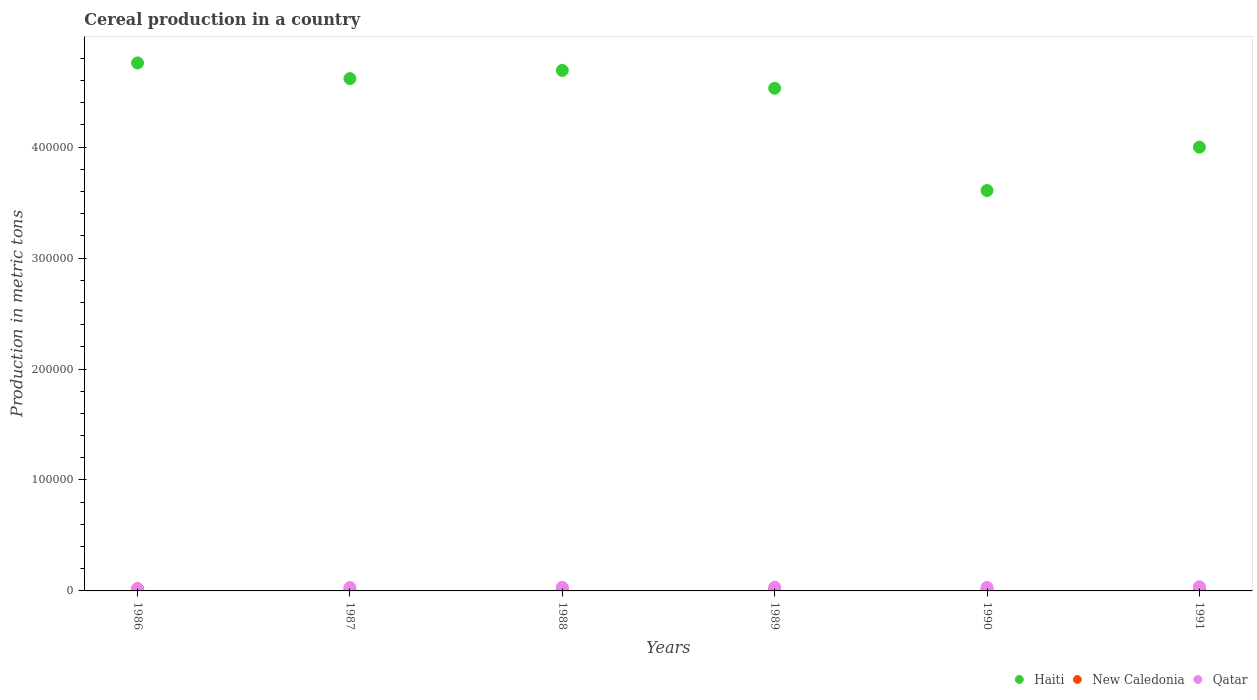Is the number of dotlines equal to the number of legend labels?
Keep it short and to the point. Yes. What is the total cereal production in Qatar in 1990?
Your answer should be very brief. 3135. Across all years, what is the maximum total cereal production in Haiti?
Offer a very short reply. 4.76e+05. Across all years, what is the minimum total cereal production in New Caledonia?
Your answer should be compact. 692. In which year was the total cereal production in Qatar minimum?
Provide a succinct answer. 1986. What is the total total cereal production in New Caledonia in the graph?
Provide a short and direct response. 6410. What is the difference between the total cereal production in New Caledonia in 1988 and that in 1991?
Provide a short and direct response. 263. What is the difference between the total cereal production in New Caledonia in 1991 and the total cereal production in Qatar in 1988?
Keep it short and to the point. -2488. What is the average total cereal production in Qatar per year?
Ensure brevity in your answer.  3067. In the year 1988, what is the difference between the total cereal production in New Caledonia and total cereal production in Qatar?
Provide a succinct answer. -2225. What is the ratio of the total cereal production in New Caledonia in 1989 to that in 1991?
Provide a succinct answer. 1.08. Is the difference between the total cereal production in New Caledonia in 1987 and 1991 greater than the difference between the total cereal production in Qatar in 1987 and 1991?
Make the answer very short. Yes. What is the difference between the highest and the second highest total cereal production in Haiti?
Make the answer very short. 6732. What is the difference between the highest and the lowest total cereal production in Haiti?
Your answer should be compact. 1.15e+05. In how many years, is the total cereal production in Haiti greater than the average total cereal production in Haiti taken over all years?
Offer a very short reply. 4. Is the sum of the total cereal production in Haiti in 1986 and 1991 greater than the maximum total cereal production in Qatar across all years?
Offer a terse response. Yes. Does the total cereal production in New Caledonia monotonically increase over the years?
Provide a short and direct response. No. Is the total cereal production in New Caledonia strictly greater than the total cereal production in Qatar over the years?
Your answer should be very brief. No. Is the total cereal production in Haiti strictly less than the total cereal production in New Caledonia over the years?
Give a very brief answer. No. How many dotlines are there?
Provide a short and direct response. 3. How many years are there in the graph?
Provide a succinct answer. 6. What is the difference between two consecutive major ticks on the Y-axis?
Provide a short and direct response. 1.00e+05. Does the graph contain grids?
Your answer should be very brief. No. What is the title of the graph?
Your answer should be very brief. Cereal production in a country. Does "Barbados" appear as one of the legend labels in the graph?
Your response must be concise. No. What is the label or title of the Y-axis?
Give a very brief answer. Production in metric tons. What is the Production in metric tons of Haiti in 1986?
Give a very brief answer. 4.76e+05. What is the Production in metric tons in New Caledonia in 1986?
Offer a very short reply. 1947. What is the Production in metric tons in Qatar in 1986?
Ensure brevity in your answer.  1977. What is the Production in metric tons in Haiti in 1987?
Give a very brief answer. 4.62e+05. What is the Production in metric tons of New Caledonia in 1987?
Ensure brevity in your answer.  692. What is the Production in metric tons in Qatar in 1987?
Give a very brief answer. 3020. What is the Production in metric tons in Haiti in 1988?
Your answer should be compact. 4.69e+05. What is the Production in metric tons in New Caledonia in 1988?
Keep it short and to the point. 999. What is the Production in metric tons in Qatar in 1988?
Offer a very short reply. 3224. What is the Production in metric tons in Haiti in 1989?
Your answer should be compact. 4.53e+05. What is the Production in metric tons in New Caledonia in 1989?
Ensure brevity in your answer.  792. What is the Production in metric tons of Qatar in 1989?
Offer a very short reply. 3297. What is the Production in metric tons in Haiti in 1990?
Provide a short and direct response. 3.61e+05. What is the Production in metric tons of New Caledonia in 1990?
Provide a short and direct response. 1244. What is the Production in metric tons of Qatar in 1990?
Keep it short and to the point. 3135. What is the Production in metric tons in Haiti in 1991?
Provide a succinct answer. 4.00e+05. What is the Production in metric tons in New Caledonia in 1991?
Offer a terse response. 736. What is the Production in metric tons of Qatar in 1991?
Offer a terse response. 3749. Across all years, what is the maximum Production in metric tons of Haiti?
Make the answer very short. 4.76e+05. Across all years, what is the maximum Production in metric tons in New Caledonia?
Make the answer very short. 1947. Across all years, what is the maximum Production in metric tons of Qatar?
Give a very brief answer. 3749. Across all years, what is the minimum Production in metric tons of Haiti?
Keep it short and to the point. 3.61e+05. Across all years, what is the minimum Production in metric tons in New Caledonia?
Your response must be concise. 692. Across all years, what is the minimum Production in metric tons of Qatar?
Provide a short and direct response. 1977. What is the total Production in metric tons of Haiti in the graph?
Make the answer very short. 2.62e+06. What is the total Production in metric tons in New Caledonia in the graph?
Provide a short and direct response. 6410. What is the total Production in metric tons of Qatar in the graph?
Keep it short and to the point. 1.84e+04. What is the difference between the Production in metric tons of Haiti in 1986 and that in 1987?
Provide a succinct answer. 1.41e+04. What is the difference between the Production in metric tons in New Caledonia in 1986 and that in 1987?
Offer a very short reply. 1255. What is the difference between the Production in metric tons in Qatar in 1986 and that in 1987?
Keep it short and to the point. -1043. What is the difference between the Production in metric tons of Haiti in 1986 and that in 1988?
Give a very brief answer. 6732. What is the difference between the Production in metric tons of New Caledonia in 1986 and that in 1988?
Your answer should be compact. 948. What is the difference between the Production in metric tons in Qatar in 1986 and that in 1988?
Your answer should be compact. -1247. What is the difference between the Production in metric tons of Haiti in 1986 and that in 1989?
Offer a terse response. 2.28e+04. What is the difference between the Production in metric tons of New Caledonia in 1986 and that in 1989?
Make the answer very short. 1155. What is the difference between the Production in metric tons of Qatar in 1986 and that in 1989?
Offer a very short reply. -1320. What is the difference between the Production in metric tons in Haiti in 1986 and that in 1990?
Provide a short and direct response. 1.15e+05. What is the difference between the Production in metric tons in New Caledonia in 1986 and that in 1990?
Provide a succinct answer. 703. What is the difference between the Production in metric tons in Qatar in 1986 and that in 1990?
Provide a short and direct response. -1158. What is the difference between the Production in metric tons in Haiti in 1986 and that in 1991?
Keep it short and to the point. 7.59e+04. What is the difference between the Production in metric tons in New Caledonia in 1986 and that in 1991?
Your answer should be very brief. 1211. What is the difference between the Production in metric tons of Qatar in 1986 and that in 1991?
Provide a succinct answer. -1772. What is the difference between the Production in metric tons of Haiti in 1987 and that in 1988?
Your answer should be very brief. -7377. What is the difference between the Production in metric tons in New Caledonia in 1987 and that in 1988?
Offer a terse response. -307. What is the difference between the Production in metric tons in Qatar in 1987 and that in 1988?
Offer a very short reply. -204. What is the difference between the Production in metric tons of Haiti in 1987 and that in 1989?
Keep it short and to the point. 8706. What is the difference between the Production in metric tons in New Caledonia in 1987 and that in 1989?
Make the answer very short. -100. What is the difference between the Production in metric tons of Qatar in 1987 and that in 1989?
Provide a short and direct response. -277. What is the difference between the Production in metric tons in Haiti in 1987 and that in 1990?
Provide a short and direct response. 1.01e+05. What is the difference between the Production in metric tons in New Caledonia in 1987 and that in 1990?
Give a very brief answer. -552. What is the difference between the Production in metric tons of Qatar in 1987 and that in 1990?
Ensure brevity in your answer.  -115. What is the difference between the Production in metric tons of Haiti in 1987 and that in 1991?
Make the answer very short. 6.18e+04. What is the difference between the Production in metric tons in New Caledonia in 1987 and that in 1991?
Offer a terse response. -44. What is the difference between the Production in metric tons of Qatar in 1987 and that in 1991?
Give a very brief answer. -729. What is the difference between the Production in metric tons in Haiti in 1988 and that in 1989?
Your answer should be compact. 1.61e+04. What is the difference between the Production in metric tons in New Caledonia in 1988 and that in 1989?
Your answer should be very brief. 207. What is the difference between the Production in metric tons of Qatar in 1988 and that in 1989?
Make the answer very short. -73. What is the difference between the Production in metric tons of Haiti in 1988 and that in 1990?
Offer a very short reply. 1.08e+05. What is the difference between the Production in metric tons in New Caledonia in 1988 and that in 1990?
Make the answer very short. -245. What is the difference between the Production in metric tons in Qatar in 1988 and that in 1990?
Ensure brevity in your answer.  89. What is the difference between the Production in metric tons of Haiti in 1988 and that in 1991?
Ensure brevity in your answer.  6.92e+04. What is the difference between the Production in metric tons in New Caledonia in 1988 and that in 1991?
Provide a succinct answer. 263. What is the difference between the Production in metric tons of Qatar in 1988 and that in 1991?
Make the answer very short. -525. What is the difference between the Production in metric tons in Haiti in 1989 and that in 1990?
Offer a very short reply. 9.22e+04. What is the difference between the Production in metric tons in New Caledonia in 1989 and that in 1990?
Give a very brief answer. -452. What is the difference between the Production in metric tons in Qatar in 1989 and that in 1990?
Keep it short and to the point. 162. What is the difference between the Production in metric tons in Haiti in 1989 and that in 1991?
Provide a short and direct response. 5.31e+04. What is the difference between the Production in metric tons of Qatar in 1989 and that in 1991?
Provide a succinct answer. -452. What is the difference between the Production in metric tons in Haiti in 1990 and that in 1991?
Make the answer very short. -3.91e+04. What is the difference between the Production in metric tons in New Caledonia in 1990 and that in 1991?
Offer a terse response. 508. What is the difference between the Production in metric tons in Qatar in 1990 and that in 1991?
Your answer should be compact. -614. What is the difference between the Production in metric tons of Haiti in 1986 and the Production in metric tons of New Caledonia in 1987?
Your answer should be very brief. 4.75e+05. What is the difference between the Production in metric tons in Haiti in 1986 and the Production in metric tons in Qatar in 1987?
Ensure brevity in your answer.  4.73e+05. What is the difference between the Production in metric tons of New Caledonia in 1986 and the Production in metric tons of Qatar in 1987?
Your answer should be compact. -1073. What is the difference between the Production in metric tons in Haiti in 1986 and the Production in metric tons in New Caledonia in 1988?
Offer a terse response. 4.75e+05. What is the difference between the Production in metric tons of Haiti in 1986 and the Production in metric tons of Qatar in 1988?
Keep it short and to the point. 4.73e+05. What is the difference between the Production in metric tons of New Caledonia in 1986 and the Production in metric tons of Qatar in 1988?
Your answer should be compact. -1277. What is the difference between the Production in metric tons of Haiti in 1986 and the Production in metric tons of New Caledonia in 1989?
Your answer should be very brief. 4.75e+05. What is the difference between the Production in metric tons of Haiti in 1986 and the Production in metric tons of Qatar in 1989?
Provide a succinct answer. 4.73e+05. What is the difference between the Production in metric tons in New Caledonia in 1986 and the Production in metric tons in Qatar in 1989?
Your answer should be very brief. -1350. What is the difference between the Production in metric tons in Haiti in 1986 and the Production in metric tons in New Caledonia in 1990?
Provide a succinct answer. 4.75e+05. What is the difference between the Production in metric tons in Haiti in 1986 and the Production in metric tons in Qatar in 1990?
Give a very brief answer. 4.73e+05. What is the difference between the Production in metric tons in New Caledonia in 1986 and the Production in metric tons in Qatar in 1990?
Provide a succinct answer. -1188. What is the difference between the Production in metric tons in Haiti in 1986 and the Production in metric tons in New Caledonia in 1991?
Provide a short and direct response. 4.75e+05. What is the difference between the Production in metric tons of Haiti in 1986 and the Production in metric tons of Qatar in 1991?
Give a very brief answer. 4.72e+05. What is the difference between the Production in metric tons of New Caledonia in 1986 and the Production in metric tons of Qatar in 1991?
Offer a terse response. -1802. What is the difference between the Production in metric tons in Haiti in 1987 and the Production in metric tons in New Caledonia in 1988?
Your answer should be compact. 4.61e+05. What is the difference between the Production in metric tons in Haiti in 1987 and the Production in metric tons in Qatar in 1988?
Make the answer very short. 4.59e+05. What is the difference between the Production in metric tons of New Caledonia in 1987 and the Production in metric tons of Qatar in 1988?
Offer a terse response. -2532. What is the difference between the Production in metric tons in Haiti in 1987 and the Production in metric tons in New Caledonia in 1989?
Keep it short and to the point. 4.61e+05. What is the difference between the Production in metric tons of Haiti in 1987 and the Production in metric tons of Qatar in 1989?
Provide a short and direct response. 4.59e+05. What is the difference between the Production in metric tons of New Caledonia in 1987 and the Production in metric tons of Qatar in 1989?
Keep it short and to the point. -2605. What is the difference between the Production in metric tons in Haiti in 1987 and the Production in metric tons in New Caledonia in 1990?
Provide a succinct answer. 4.61e+05. What is the difference between the Production in metric tons of Haiti in 1987 and the Production in metric tons of Qatar in 1990?
Provide a short and direct response. 4.59e+05. What is the difference between the Production in metric tons of New Caledonia in 1987 and the Production in metric tons of Qatar in 1990?
Ensure brevity in your answer.  -2443. What is the difference between the Production in metric tons in Haiti in 1987 and the Production in metric tons in New Caledonia in 1991?
Give a very brief answer. 4.61e+05. What is the difference between the Production in metric tons of Haiti in 1987 and the Production in metric tons of Qatar in 1991?
Give a very brief answer. 4.58e+05. What is the difference between the Production in metric tons of New Caledonia in 1987 and the Production in metric tons of Qatar in 1991?
Provide a short and direct response. -3057. What is the difference between the Production in metric tons of Haiti in 1988 and the Production in metric tons of New Caledonia in 1989?
Offer a very short reply. 4.68e+05. What is the difference between the Production in metric tons in Haiti in 1988 and the Production in metric tons in Qatar in 1989?
Provide a succinct answer. 4.66e+05. What is the difference between the Production in metric tons of New Caledonia in 1988 and the Production in metric tons of Qatar in 1989?
Provide a succinct answer. -2298. What is the difference between the Production in metric tons in Haiti in 1988 and the Production in metric tons in New Caledonia in 1990?
Provide a succinct answer. 4.68e+05. What is the difference between the Production in metric tons in Haiti in 1988 and the Production in metric tons in Qatar in 1990?
Your answer should be very brief. 4.66e+05. What is the difference between the Production in metric tons in New Caledonia in 1988 and the Production in metric tons in Qatar in 1990?
Provide a short and direct response. -2136. What is the difference between the Production in metric tons of Haiti in 1988 and the Production in metric tons of New Caledonia in 1991?
Offer a terse response. 4.68e+05. What is the difference between the Production in metric tons in Haiti in 1988 and the Production in metric tons in Qatar in 1991?
Make the answer very short. 4.65e+05. What is the difference between the Production in metric tons of New Caledonia in 1988 and the Production in metric tons of Qatar in 1991?
Give a very brief answer. -2750. What is the difference between the Production in metric tons of Haiti in 1989 and the Production in metric tons of New Caledonia in 1990?
Make the answer very short. 4.52e+05. What is the difference between the Production in metric tons in Haiti in 1989 and the Production in metric tons in Qatar in 1990?
Your answer should be very brief. 4.50e+05. What is the difference between the Production in metric tons of New Caledonia in 1989 and the Production in metric tons of Qatar in 1990?
Make the answer very short. -2343. What is the difference between the Production in metric tons in Haiti in 1989 and the Production in metric tons in New Caledonia in 1991?
Give a very brief answer. 4.52e+05. What is the difference between the Production in metric tons of Haiti in 1989 and the Production in metric tons of Qatar in 1991?
Your response must be concise. 4.49e+05. What is the difference between the Production in metric tons in New Caledonia in 1989 and the Production in metric tons in Qatar in 1991?
Make the answer very short. -2957. What is the difference between the Production in metric tons in Haiti in 1990 and the Production in metric tons in New Caledonia in 1991?
Provide a short and direct response. 3.60e+05. What is the difference between the Production in metric tons of Haiti in 1990 and the Production in metric tons of Qatar in 1991?
Your answer should be compact. 3.57e+05. What is the difference between the Production in metric tons in New Caledonia in 1990 and the Production in metric tons in Qatar in 1991?
Provide a succinct answer. -2505. What is the average Production in metric tons in Haiti per year?
Provide a short and direct response. 4.37e+05. What is the average Production in metric tons in New Caledonia per year?
Give a very brief answer. 1068.33. What is the average Production in metric tons of Qatar per year?
Provide a succinct answer. 3067. In the year 1986, what is the difference between the Production in metric tons in Haiti and Production in metric tons in New Caledonia?
Your response must be concise. 4.74e+05. In the year 1986, what is the difference between the Production in metric tons in Haiti and Production in metric tons in Qatar?
Your response must be concise. 4.74e+05. In the year 1986, what is the difference between the Production in metric tons in New Caledonia and Production in metric tons in Qatar?
Your response must be concise. -30. In the year 1987, what is the difference between the Production in metric tons of Haiti and Production in metric tons of New Caledonia?
Ensure brevity in your answer.  4.61e+05. In the year 1987, what is the difference between the Production in metric tons in Haiti and Production in metric tons in Qatar?
Keep it short and to the point. 4.59e+05. In the year 1987, what is the difference between the Production in metric tons in New Caledonia and Production in metric tons in Qatar?
Provide a succinct answer. -2328. In the year 1988, what is the difference between the Production in metric tons in Haiti and Production in metric tons in New Caledonia?
Your answer should be very brief. 4.68e+05. In the year 1988, what is the difference between the Production in metric tons of Haiti and Production in metric tons of Qatar?
Offer a very short reply. 4.66e+05. In the year 1988, what is the difference between the Production in metric tons of New Caledonia and Production in metric tons of Qatar?
Make the answer very short. -2225. In the year 1989, what is the difference between the Production in metric tons in Haiti and Production in metric tons in New Caledonia?
Your answer should be compact. 4.52e+05. In the year 1989, what is the difference between the Production in metric tons of Haiti and Production in metric tons of Qatar?
Keep it short and to the point. 4.50e+05. In the year 1989, what is the difference between the Production in metric tons of New Caledonia and Production in metric tons of Qatar?
Your response must be concise. -2505. In the year 1990, what is the difference between the Production in metric tons in Haiti and Production in metric tons in New Caledonia?
Your answer should be very brief. 3.60e+05. In the year 1990, what is the difference between the Production in metric tons of Haiti and Production in metric tons of Qatar?
Your answer should be compact. 3.58e+05. In the year 1990, what is the difference between the Production in metric tons of New Caledonia and Production in metric tons of Qatar?
Your response must be concise. -1891. In the year 1991, what is the difference between the Production in metric tons in Haiti and Production in metric tons in New Caledonia?
Ensure brevity in your answer.  3.99e+05. In the year 1991, what is the difference between the Production in metric tons of Haiti and Production in metric tons of Qatar?
Ensure brevity in your answer.  3.96e+05. In the year 1991, what is the difference between the Production in metric tons in New Caledonia and Production in metric tons in Qatar?
Make the answer very short. -3013. What is the ratio of the Production in metric tons of Haiti in 1986 to that in 1987?
Your answer should be compact. 1.03. What is the ratio of the Production in metric tons in New Caledonia in 1986 to that in 1987?
Give a very brief answer. 2.81. What is the ratio of the Production in metric tons of Qatar in 1986 to that in 1987?
Ensure brevity in your answer.  0.65. What is the ratio of the Production in metric tons in Haiti in 1986 to that in 1988?
Keep it short and to the point. 1.01. What is the ratio of the Production in metric tons of New Caledonia in 1986 to that in 1988?
Keep it short and to the point. 1.95. What is the ratio of the Production in metric tons of Qatar in 1986 to that in 1988?
Provide a short and direct response. 0.61. What is the ratio of the Production in metric tons of Haiti in 1986 to that in 1989?
Provide a short and direct response. 1.05. What is the ratio of the Production in metric tons of New Caledonia in 1986 to that in 1989?
Give a very brief answer. 2.46. What is the ratio of the Production in metric tons in Qatar in 1986 to that in 1989?
Give a very brief answer. 0.6. What is the ratio of the Production in metric tons in Haiti in 1986 to that in 1990?
Provide a short and direct response. 1.32. What is the ratio of the Production in metric tons of New Caledonia in 1986 to that in 1990?
Offer a very short reply. 1.57. What is the ratio of the Production in metric tons of Qatar in 1986 to that in 1990?
Provide a succinct answer. 0.63. What is the ratio of the Production in metric tons in Haiti in 1986 to that in 1991?
Your response must be concise. 1.19. What is the ratio of the Production in metric tons of New Caledonia in 1986 to that in 1991?
Your answer should be compact. 2.65. What is the ratio of the Production in metric tons of Qatar in 1986 to that in 1991?
Make the answer very short. 0.53. What is the ratio of the Production in metric tons of Haiti in 1987 to that in 1988?
Provide a succinct answer. 0.98. What is the ratio of the Production in metric tons in New Caledonia in 1987 to that in 1988?
Offer a terse response. 0.69. What is the ratio of the Production in metric tons in Qatar in 1987 to that in 1988?
Your response must be concise. 0.94. What is the ratio of the Production in metric tons in Haiti in 1987 to that in 1989?
Your answer should be very brief. 1.02. What is the ratio of the Production in metric tons in New Caledonia in 1987 to that in 1989?
Provide a short and direct response. 0.87. What is the ratio of the Production in metric tons in Qatar in 1987 to that in 1989?
Ensure brevity in your answer.  0.92. What is the ratio of the Production in metric tons in Haiti in 1987 to that in 1990?
Your answer should be compact. 1.28. What is the ratio of the Production in metric tons of New Caledonia in 1987 to that in 1990?
Your answer should be compact. 0.56. What is the ratio of the Production in metric tons of Qatar in 1987 to that in 1990?
Ensure brevity in your answer.  0.96. What is the ratio of the Production in metric tons of Haiti in 1987 to that in 1991?
Give a very brief answer. 1.15. What is the ratio of the Production in metric tons of New Caledonia in 1987 to that in 1991?
Provide a succinct answer. 0.94. What is the ratio of the Production in metric tons of Qatar in 1987 to that in 1991?
Your answer should be compact. 0.81. What is the ratio of the Production in metric tons of Haiti in 1988 to that in 1989?
Offer a very short reply. 1.04. What is the ratio of the Production in metric tons in New Caledonia in 1988 to that in 1989?
Offer a very short reply. 1.26. What is the ratio of the Production in metric tons of Qatar in 1988 to that in 1989?
Provide a succinct answer. 0.98. What is the ratio of the Production in metric tons of New Caledonia in 1988 to that in 1990?
Make the answer very short. 0.8. What is the ratio of the Production in metric tons of Qatar in 1988 to that in 1990?
Your answer should be very brief. 1.03. What is the ratio of the Production in metric tons of Haiti in 1988 to that in 1991?
Provide a short and direct response. 1.17. What is the ratio of the Production in metric tons of New Caledonia in 1988 to that in 1991?
Make the answer very short. 1.36. What is the ratio of the Production in metric tons in Qatar in 1988 to that in 1991?
Offer a very short reply. 0.86. What is the ratio of the Production in metric tons in Haiti in 1989 to that in 1990?
Provide a short and direct response. 1.26. What is the ratio of the Production in metric tons in New Caledonia in 1989 to that in 1990?
Your answer should be very brief. 0.64. What is the ratio of the Production in metric tons of Qatar in 1989 to that in 1990?
Make the answer very short. 1.05. What is the ratio of the Production in metric tons of Haiti in 1989 to that in 1991?
Provide a short and direct response. 1.13. What is the ratio of the Production in metric tons of New Caledonia in 1989 to that in 1991?
Provide a short and direct response. 1.08. What is the ratio of the Production in metric tons in Qatar in 1989 to that in 1991?
Your answer should be very brief. 0.88. What is the ratio of the Production in metric tons in Haiti in 1990 to that in 1991?
Offer a terse response. 0.9. What is the ratio of the Production in metric tons in New Caledonia in 1990 to that in 1991?
Offer a very short reply. 1.69. What is the ratio of the Production in metric tons of Qatar in 1990 to that in 1991?
Ensure brevity in your answer.  0.84. What is the difference between the highest and the second highest Production in metric tons of Haiti?
Offer a terse response. 6732. What is the difference between the highest and the second highest Production in metric tons in New Caledonia?
Your response must be concise. 703. What is the difference between the highest and the second highest Production in metric tons in Qatar?
Ensure brevity in your answer.  452. What is the difference between the highest and the lowest Production in metric tons in Haiti?
Ensure brevity in your answer.  1.15e+05. What is the difference between the highest and the lowest Production in metric tons in New Caledonia?
Keep it short and to the point. 1255. What is the difference between the highest and the lowest Production in metric tons in Qatar?
Your answer should be very brief. 1772. 